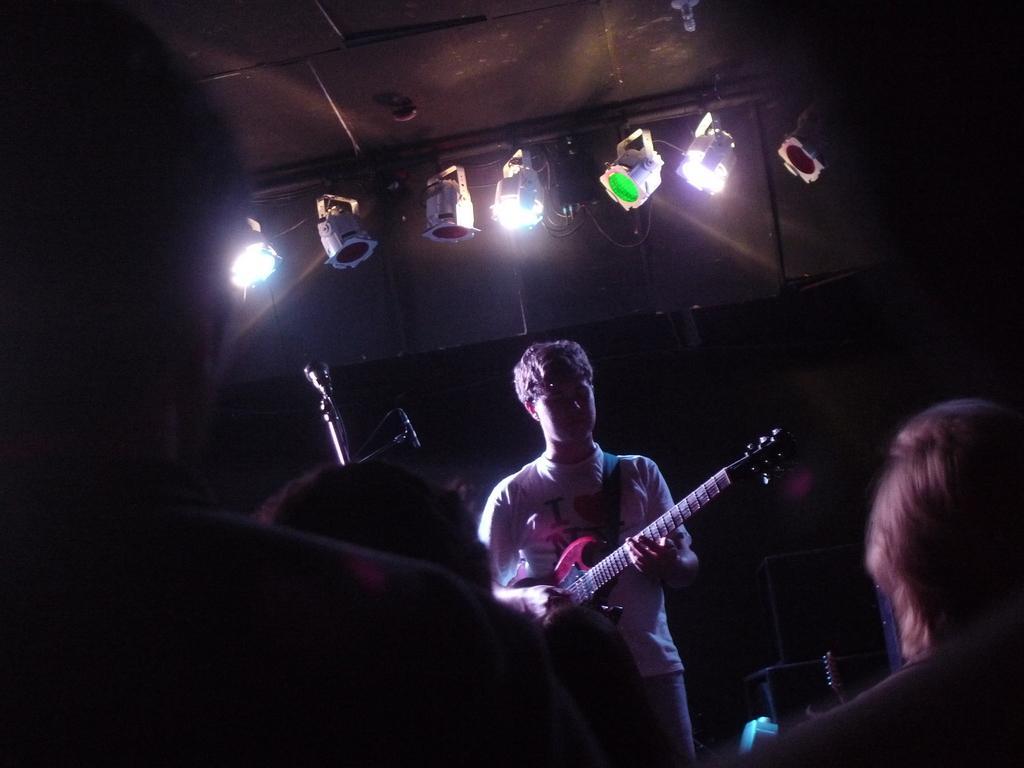In one or two sentences, can you explain what this image depicts? In this picture we can see few lights at the top. Here we can see one man playing a guitar. This is a mike. We can see few audience over here. 